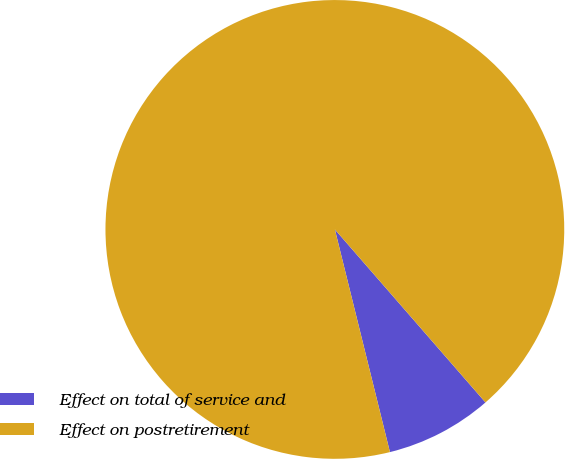Convert chart to OTSL. <chart><loc_0><loc_0><loc_500><loc_500><pie_chart><fcel>Effect on total of service and<fcel>Effect on postretirement<nl><fcel>7.54%<fcel>92.46%<nl></chart> 